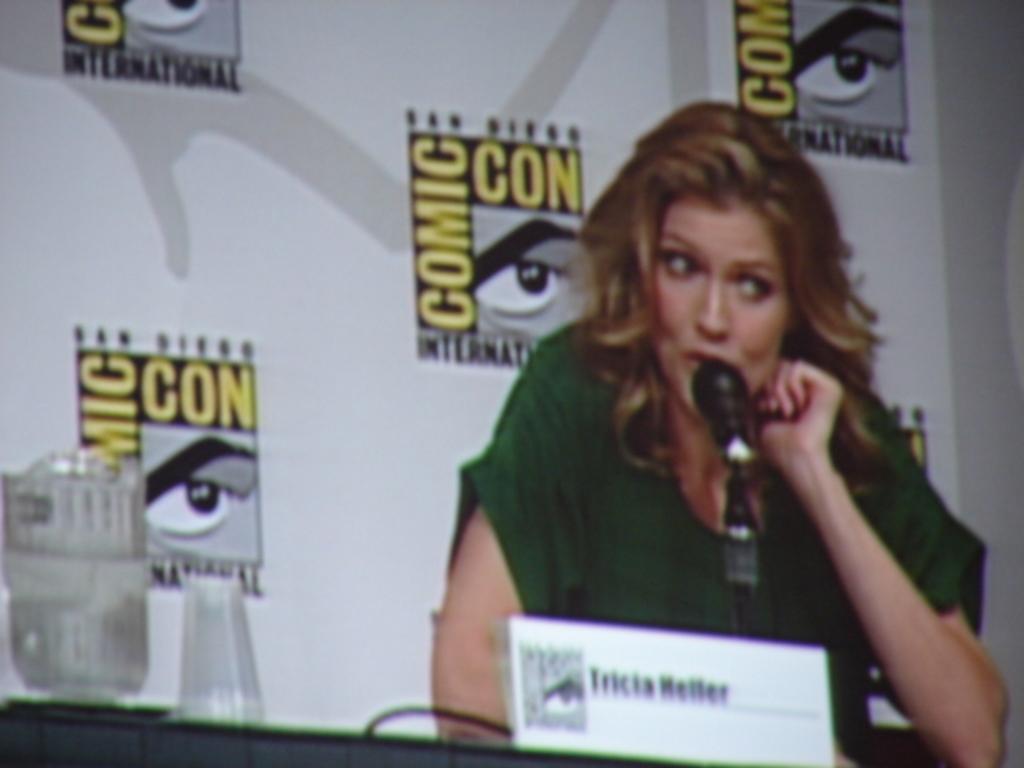In one or two sentences, can you explain what this image depicts? In this picture we can see a woman sitting near the table and she is in green T-shirt and talking into the microphone and on the table, we can see a name board and glass and behind her we can see the banner with brand symbol. 